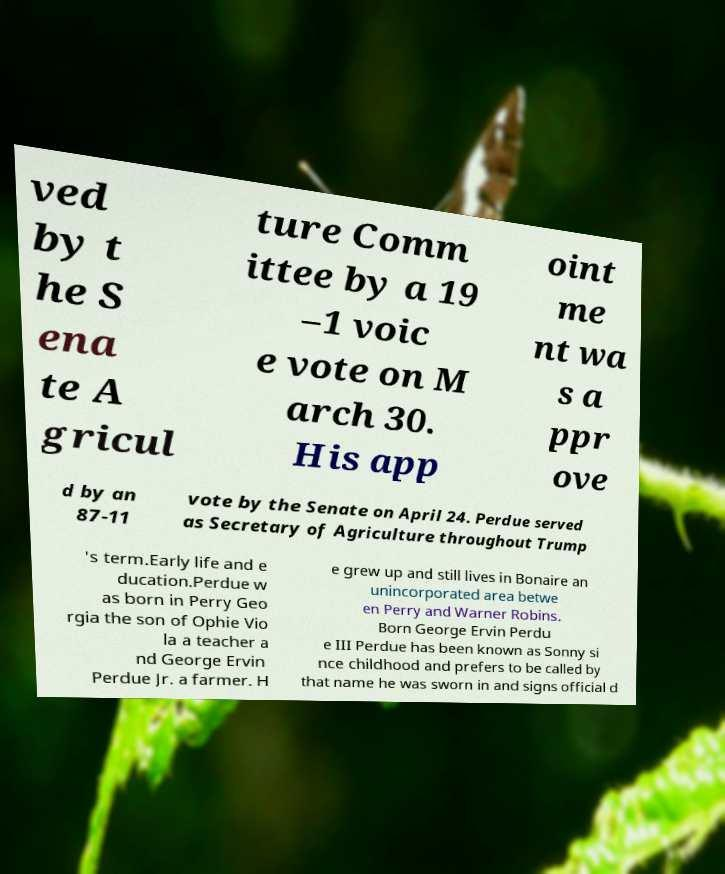Could you extract and type out the text from this image? ved by t he S ena te A gricul ture Comm ittee by a 19 –1 voic e vote on M arch 30. His app oint me nt wa s a ppr ove d by an 87-11 vote by the Senate on April 24. Perdue served as Secretary of Agriculture throughout Trump 's term.Early life and e ducation.Perdue w as born in Perry Geo rgia the son of Ophie Vio la a teacher a nd George Ervin Perdue Jr. a farmer. H e grew up and still lives in Bonaire an unincorporated area betwe en Perry and Warner Robins. Born George Ervin Perdu e III Perdue has been known as Sonny si nce childhood and prefers to be called by that name he was sworn in and signs official d 